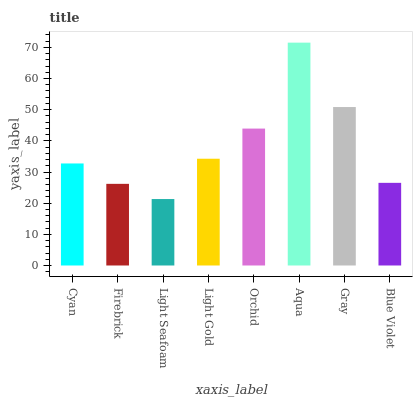Is Light Seafoam the minimum?
Answer yes or no. Yes. Is Aqua the maximum?
Answer yes or no. Yes. Is Firebrick the minimum?
Answer yes or no. No. Is Firebrick the maximum?
Answer yes or no. No. Is Cyan greater than Firebrick?
Answer yes or no. Yes. Is Firebrick less than Cyan?
Answer yes or no. Yes. Is Firebrick greater than Cyan?
Answer yes or no. No. Is Cyan less than Firebrick?
Answer yes or no. No. Is Light Gold the high median?
Answer yes or no. Yes. Is Cyan the low median?
Answer yes or no. Yes. Is Cyan the high median?
Answer yes or no. No. Is Light Gold the low median?
Answer yes or no. No. 